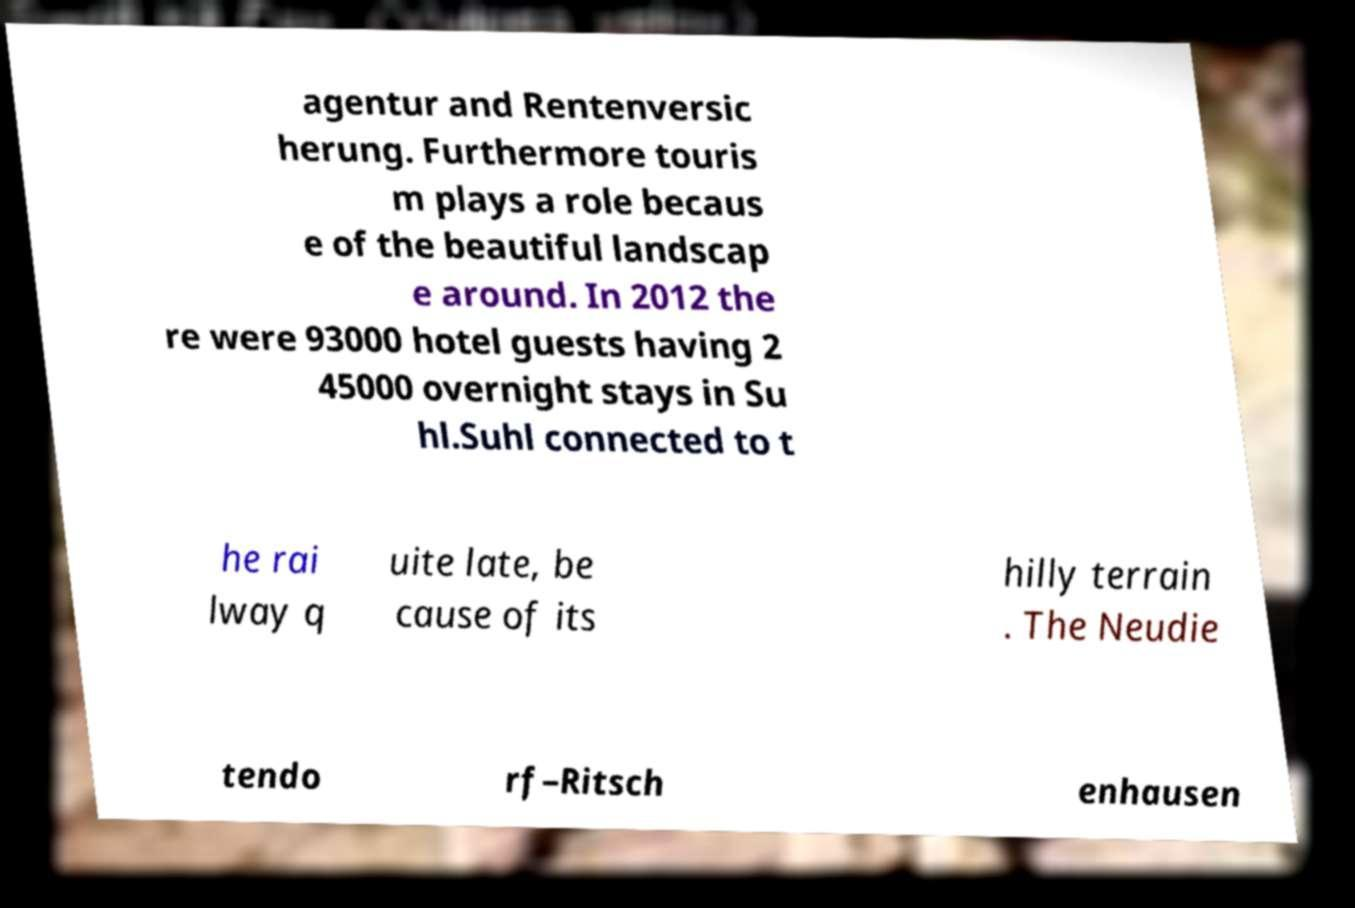What messages or text are displayed in this image? I need them in a readable, typed format. agentur and Rentenversic herung. Furthermore touris m plays a role becaus e of the beautiful landscap e around. In 2012 the re were 93000 hotel guests having 2 45000 overnight stays in Su hl.Suhl connected to t he rai lway q uite late, be cause of its hilly terrain . The Neudie tendo rf–Ritsch enhausen 